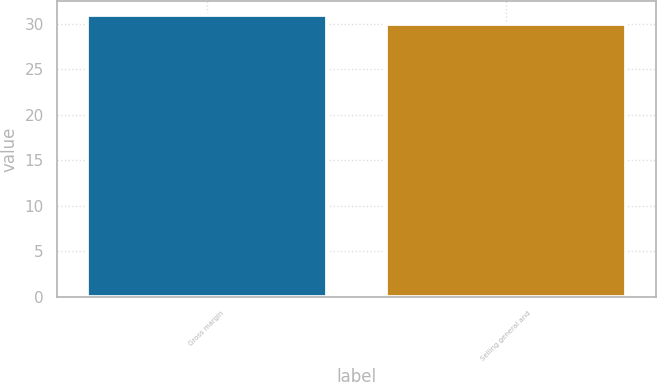<chart> <loc_0><loc_0><loc_500><loc_500><bar_chart><fcel>Gross margin<fcel>Selling general and<nl><fcel>31<fcel>30<nl></chart> 